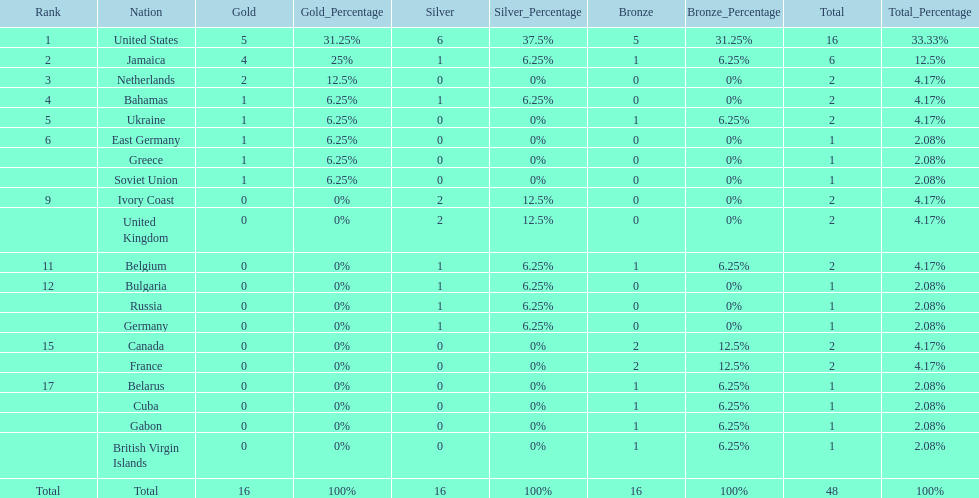How many gold medals did the us and jamaica win combined? 9. 